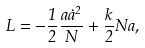<formula> <loc_0><loc_0><loc_500><loc_500>L = - \frac { 1 } { 2 } \frac { a \dot { a } ^ { 2 } } { N } + \frac { k } { 2 } N a ,</formula> 